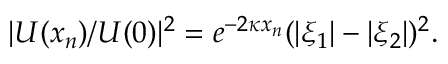Convert formula to latex. <formula><loc_0><loc_0><loc_500><loc_500>| U ( x _ { n } ) / U ( 0 ) | ^ { 2 } = e ^ { - 2 \kappa x _ { n } } ( | \xi _ { 1 } | - | \xi _ { 2 } | ) ^ { 2 } .</formula> 